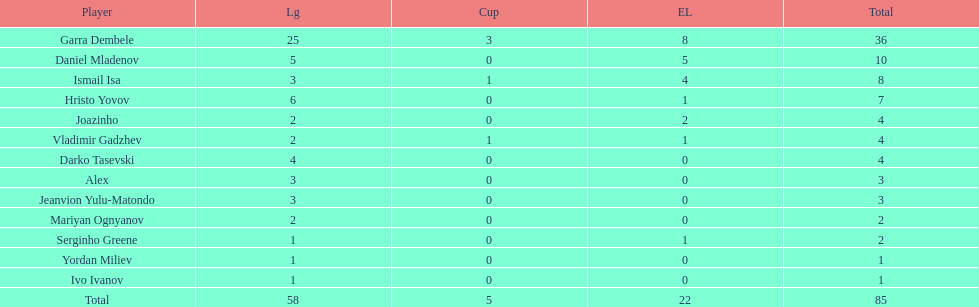How many of the players did not score any goals in the cup? 10. 